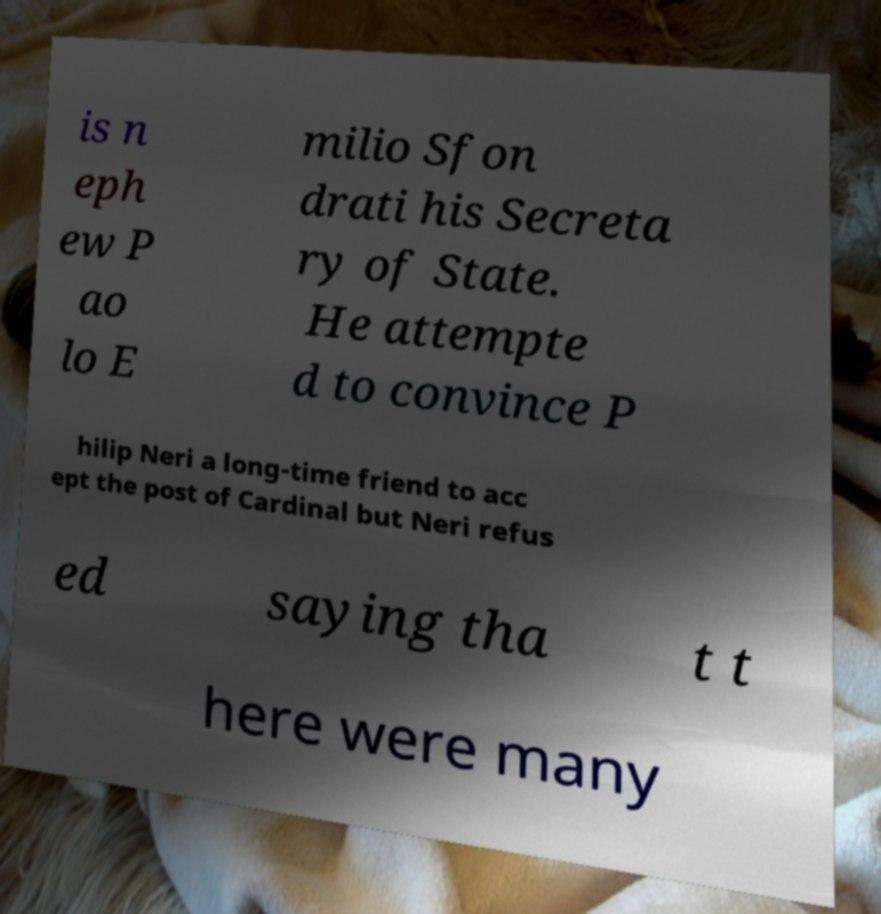Could you assist in decoding the text presented in this image and type it out clearly? is n eph ew P ao lo E milio Sfon drati his Secreta ry of State. He attempte d to convince P hilip Neri a long-time friend to acc ept the post of Cardinal but Neri refus ed saying tha t t here were many 